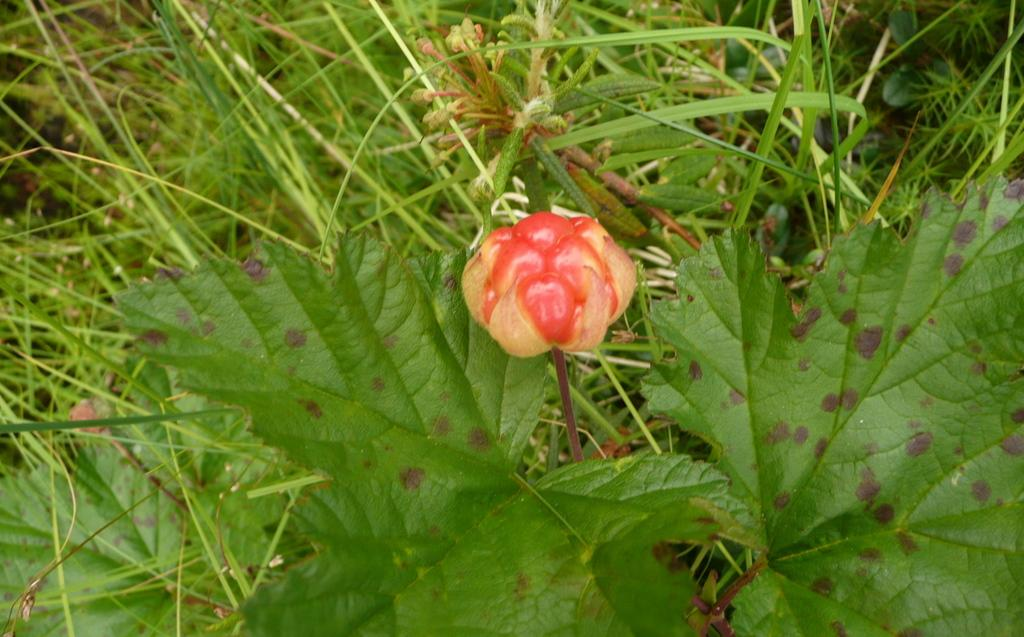What type of living organisms can be seen in the image? Plants can be seen in the image. Can you describe the main feature of the image? There is a flower in the center of the image. Are there any cobwebs visible in the image? There is no mention of cobwebs in the provided facts, and therefore we cannot determine if any are present in the image. 